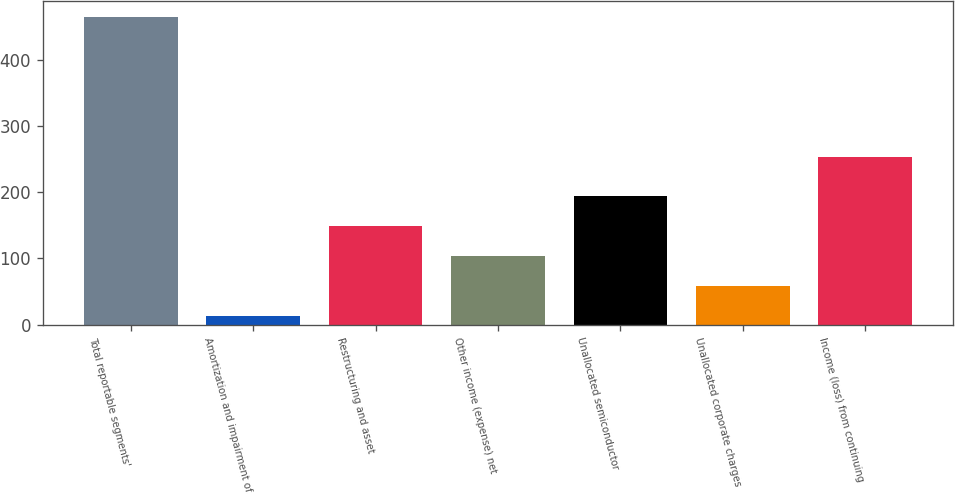<chart> <loc_0><loc_0><loc_500><loc_500><bar_chart><fcel>Total reportable segments'<fcel>Amortization and impairment of<fcel>Restructuring and asset<fcel>Other income (expense) net<fcel>Unallocated semiconductor<fcel>Unallocated corporate charges<fcel>Income (loss) from continuing<nl><fcel>466<fcel>13<fcel>148.9<fcel>103.6<fcel>194.2<fcel>58.3<fcel>254<nl></chart> 